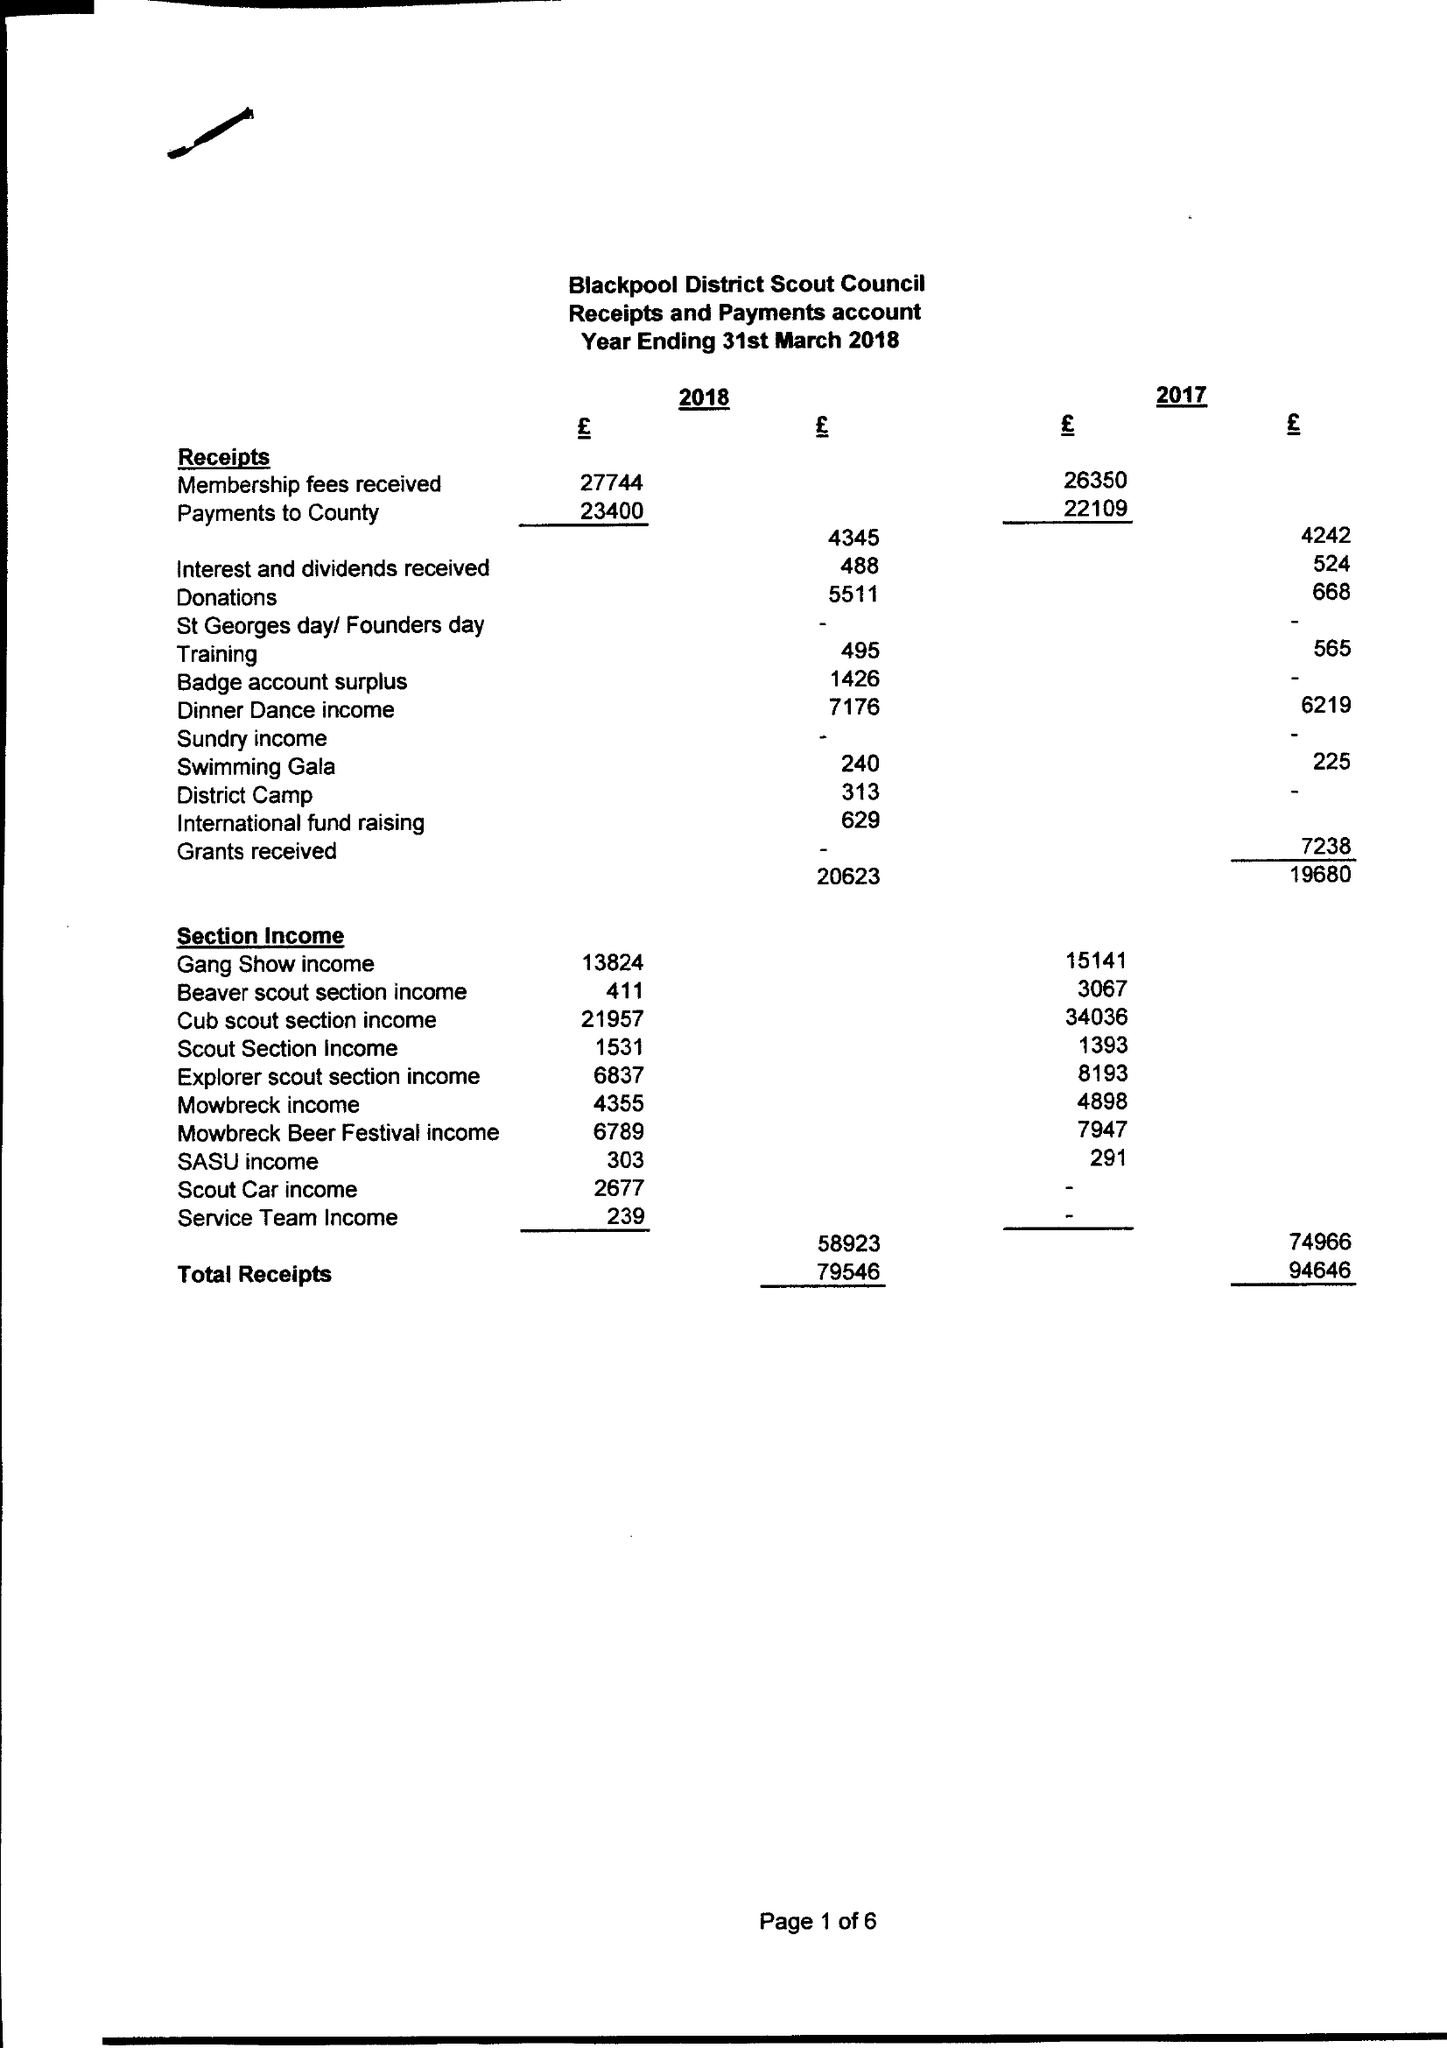What is the value for the address__postcode?
Answer the question using a single word or phrase. FY3 9PQ 